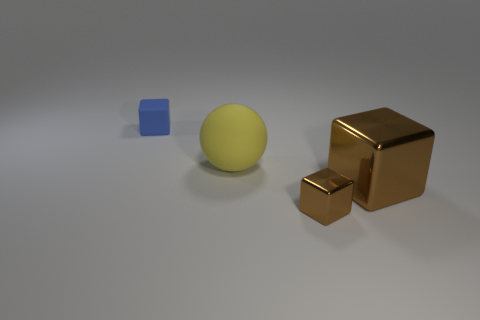Are there fewer cubes behind the rubber block than large brown metallic blocks that are in front of the small brown metal block? Actually, the image contains one blue cube, one yellow sphere, and two brown metallic blocks, one larger and one smaller. There are no cubes behind the yellow sphere, and both metallic blocks are positioned in front of the sphere, with no additional cubes in the scene. Therefore, the number of cubes behind the yellow sphere cannot be compared to metallic blocks in front of other items as there are no such cubes present. 